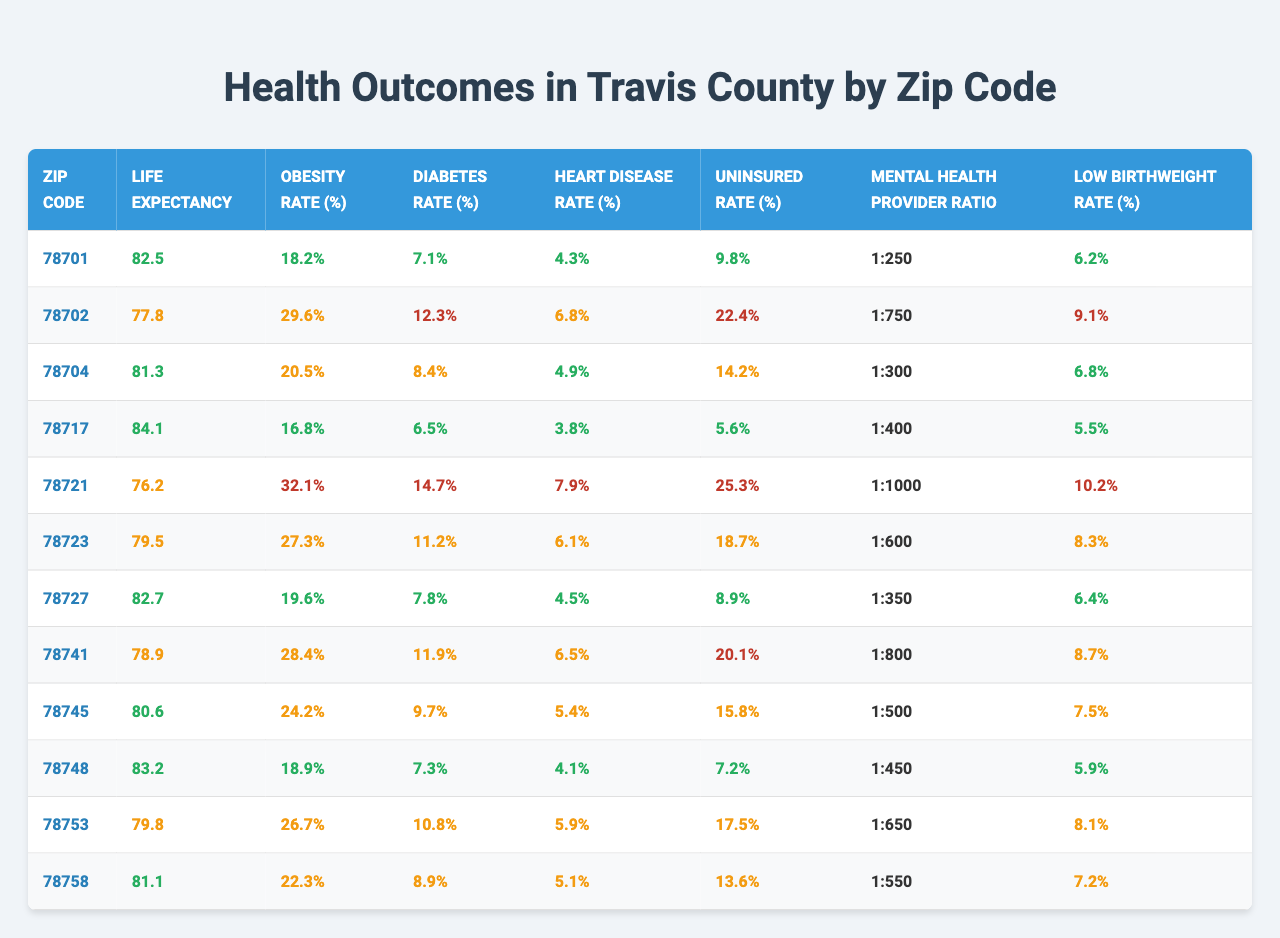What's the life expectancy in zip code 78721? The life expectancy for zip code 78721 is listed in the table as 76.2 years.
Answer: 76.2 What is the obesity rate in the zip code 78704? The table indicates that the obesity rate in zip code 78704 is 20.5%.
Answer: 20.5% Which zip code has the highest diabetes rate? By examining the diabetes rates in the table, zip code 78721 has the highest diabetes rate at 14.7%.
Answer: 78721 What is the uninsured rate for zip code 78702? According to the table, the uninsured rate for zip code 78702 is 22.4%.
Answer: 22.4% How many zip codes have a life expectancy above 80 years? The zip codes with life expectancy above 80 years are 78701, 78717, 78727, 78748, totaling four zip codes.
Answer: 4 Is the heart disease rate higher in zip code 78741 than in 78745? The heart disease rate in zip code 78741 is 6.5%, while in zip code 78745 it is 5.4%, indicating that 78741 has a higher rate.
Answer: Yes What is the average uninsured rate for the zip codes listed in the table? The total uninsured rates are 9.8, 22.4, 14.2, 5.6, 25.3, 18.7, 8.9, 20.1, 15.8, 7.2, 17.5, 13.6 giving a total of  182.5 for 12 zip codes; the average is 182.5/12 = 15.21%.
Answer: 15.21% Which zip code has the lowest low birthweight rate? The lowest low birthweight rate is found in zip code 78748, which has a rate of 5.9%.
Answer: 78748 If we compare the life expectancy and obesity rate, which zip code has a lower life expectancy and a higher obesity rate than the overall averages (average life expectancy ~ 80.2 years, average obesity rate ~ 23.1%)? Zip code 78721 has a life expectancy of 76.2 years and an obesity rate of 32.1%, both below the life expectancy average and above the obesity rate average.
Answer: 78721 Is the mental health provider ratio better in zip code 78704 compared to 78727? The mental health provider ratio for 78704 is 1:300, while for 78727 it is 1:350. A lower denominator indicates better access; therefore, 78704 has a better ratio than 78727.
Answer: Yes 